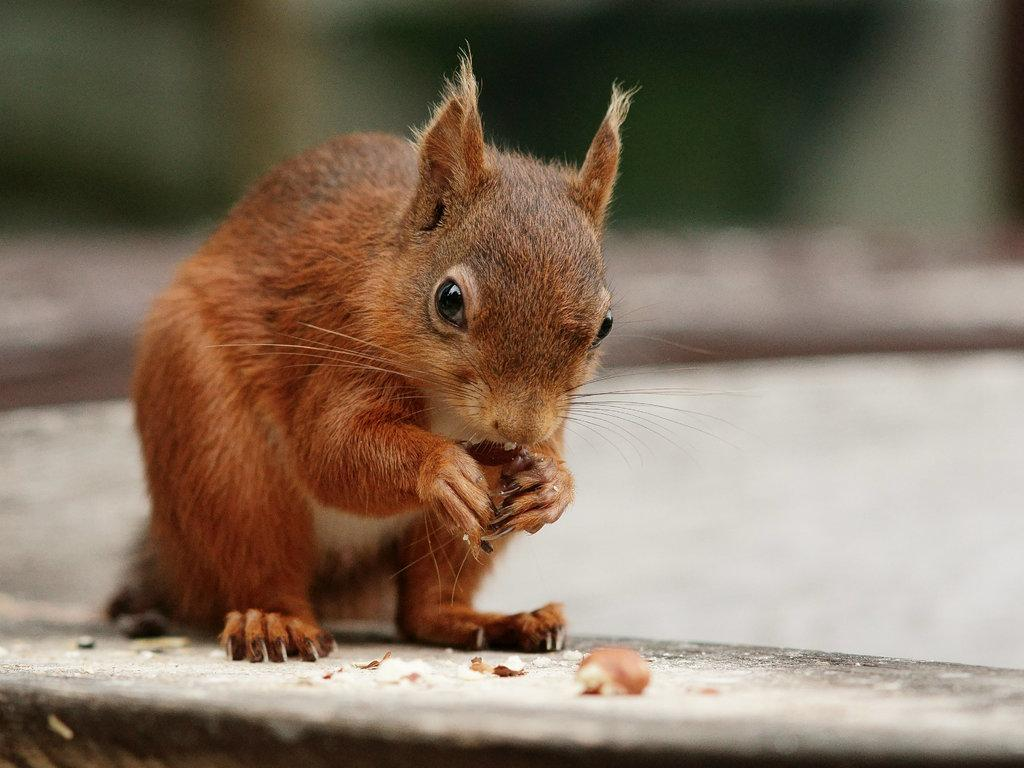What type of animal is in the image? There is a squirrel in the image. What color is the squirrel? The squirrel is brown in color. Where is the squirrel located in the image? The squirrel is on the road. Can you describe the background of the image? The background of the image is blurred. What type of jeans is the beggar wearing in the image? There is no beggar or jeans present in the image; it features a brown squirrel on the road with a blurred background. 